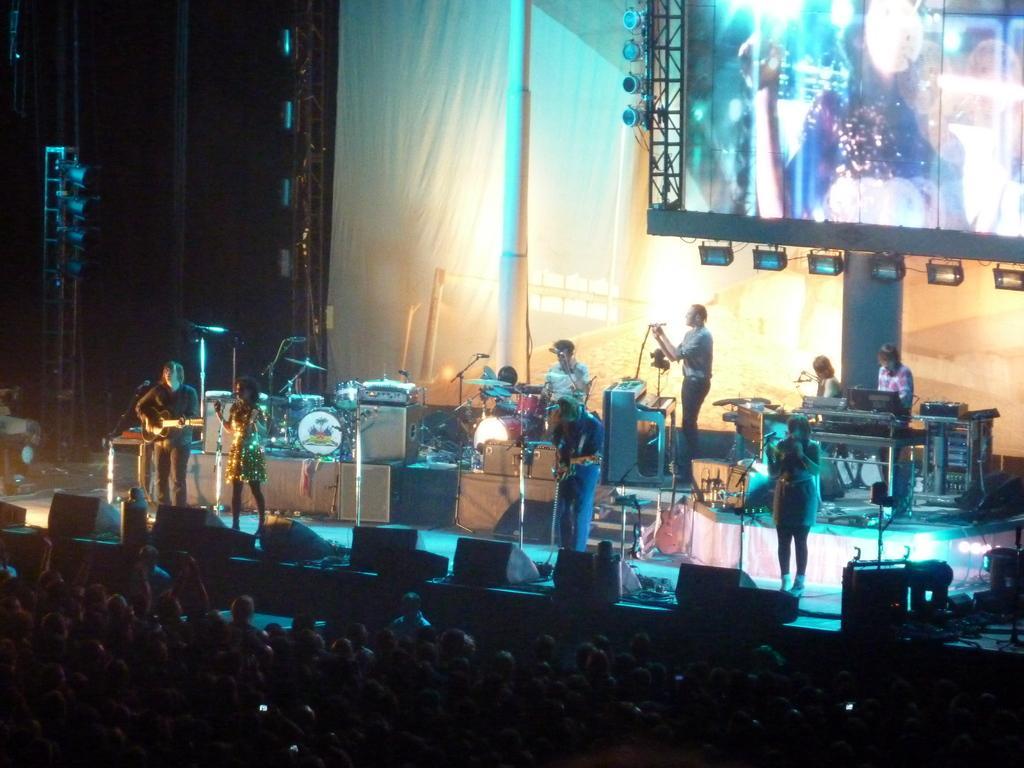Can you describe this image briefly? This image is taken in a concert. At the bottom of the image there are many people. In the background there is a poster and a screen with lights. In the middle of the image there are many musical instruments. A few people are sitting and playing the music and a few standing and singing. A man is standing and playing the music with a guitar. 